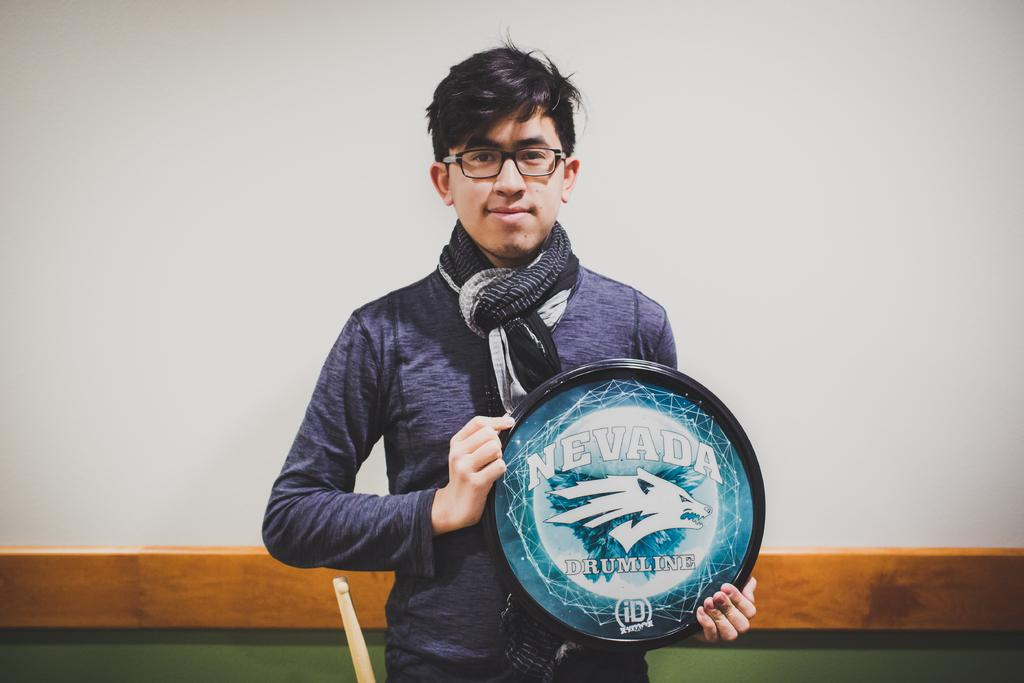What is the main subject of the image? The main subject of the image is a man. What is the man doing in the image? The man is standing in the image. What is the man holding in his hands? The man is holding a memento in his hands. What type of kite is the man flying in the image? There is no kite present in the image; the man is holding a memento. How does the man play with the kite in the image? There is no kite present in the image, so the man cannot play with one. 